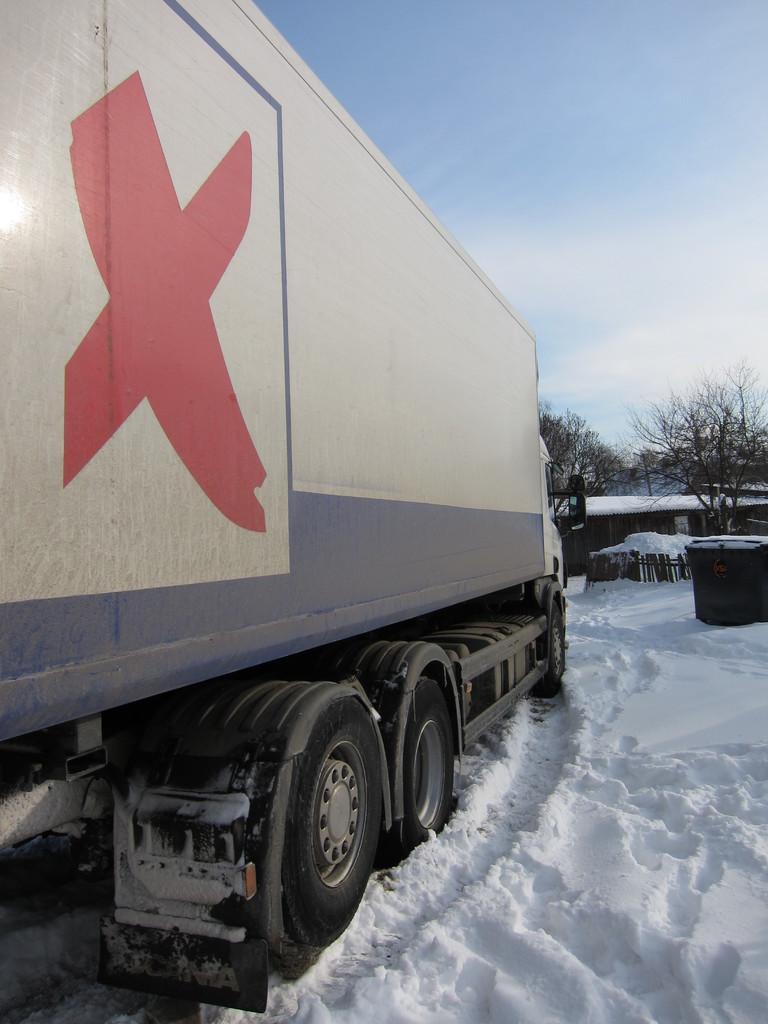Please provide a concise description of this image. In this picture we can see a vehicle in the snow and in front of the vehicle there are trees, house, sky and an object. 